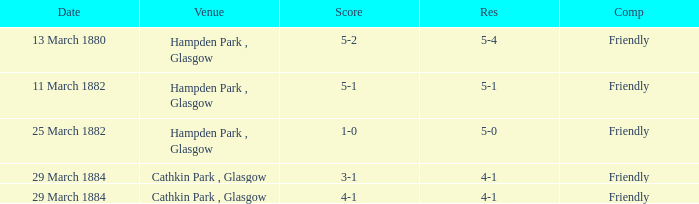Which item has a score of 5-1? 5-1. 